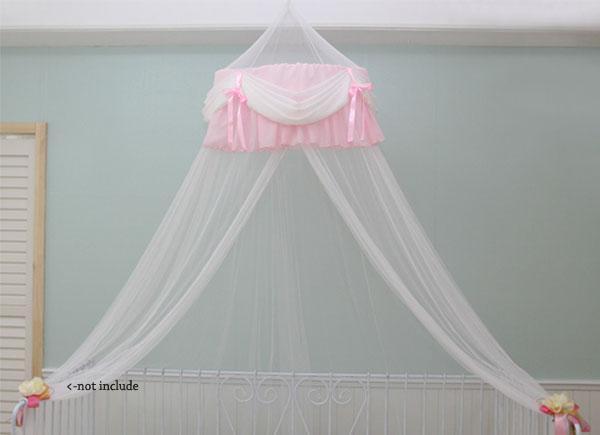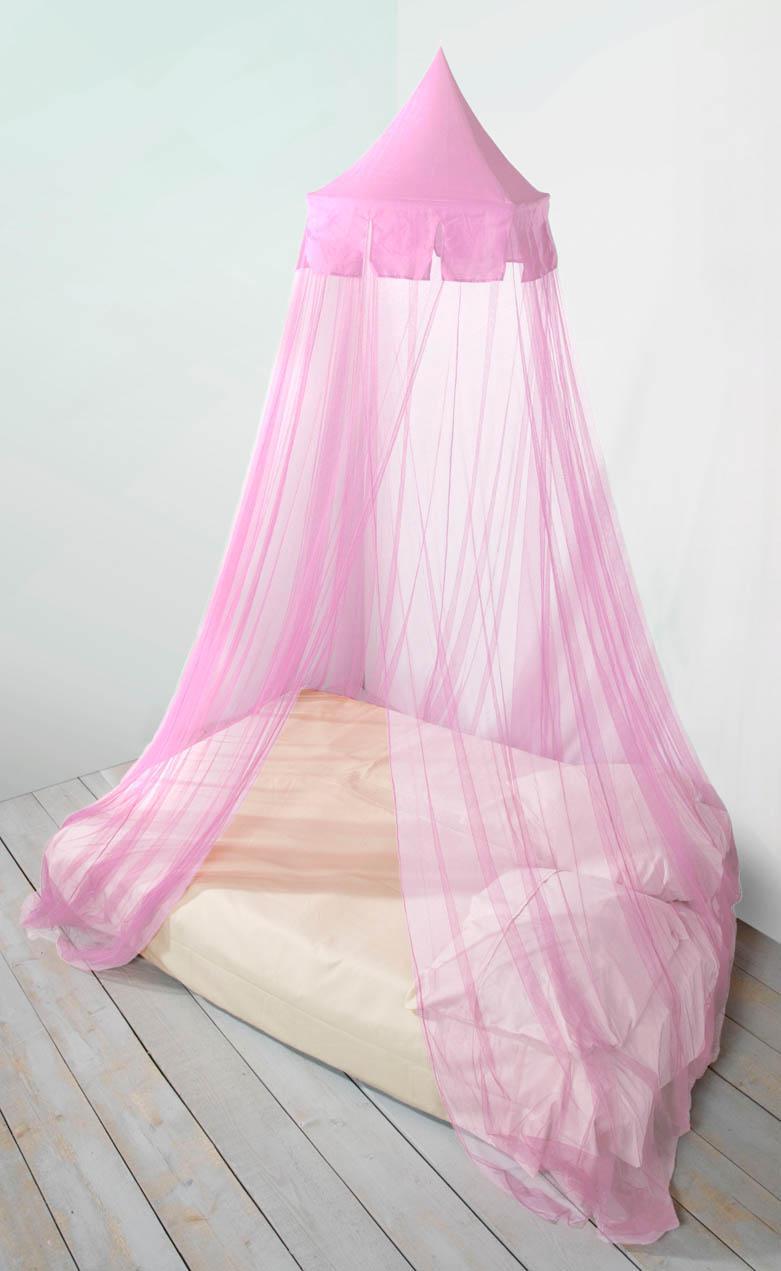The first image is the image on the left, the second image is the image on the right. Analyze the images presented: Is the assertion "Only two pillows are visible ont he right image." valid? Answer yes or no. Yes. 